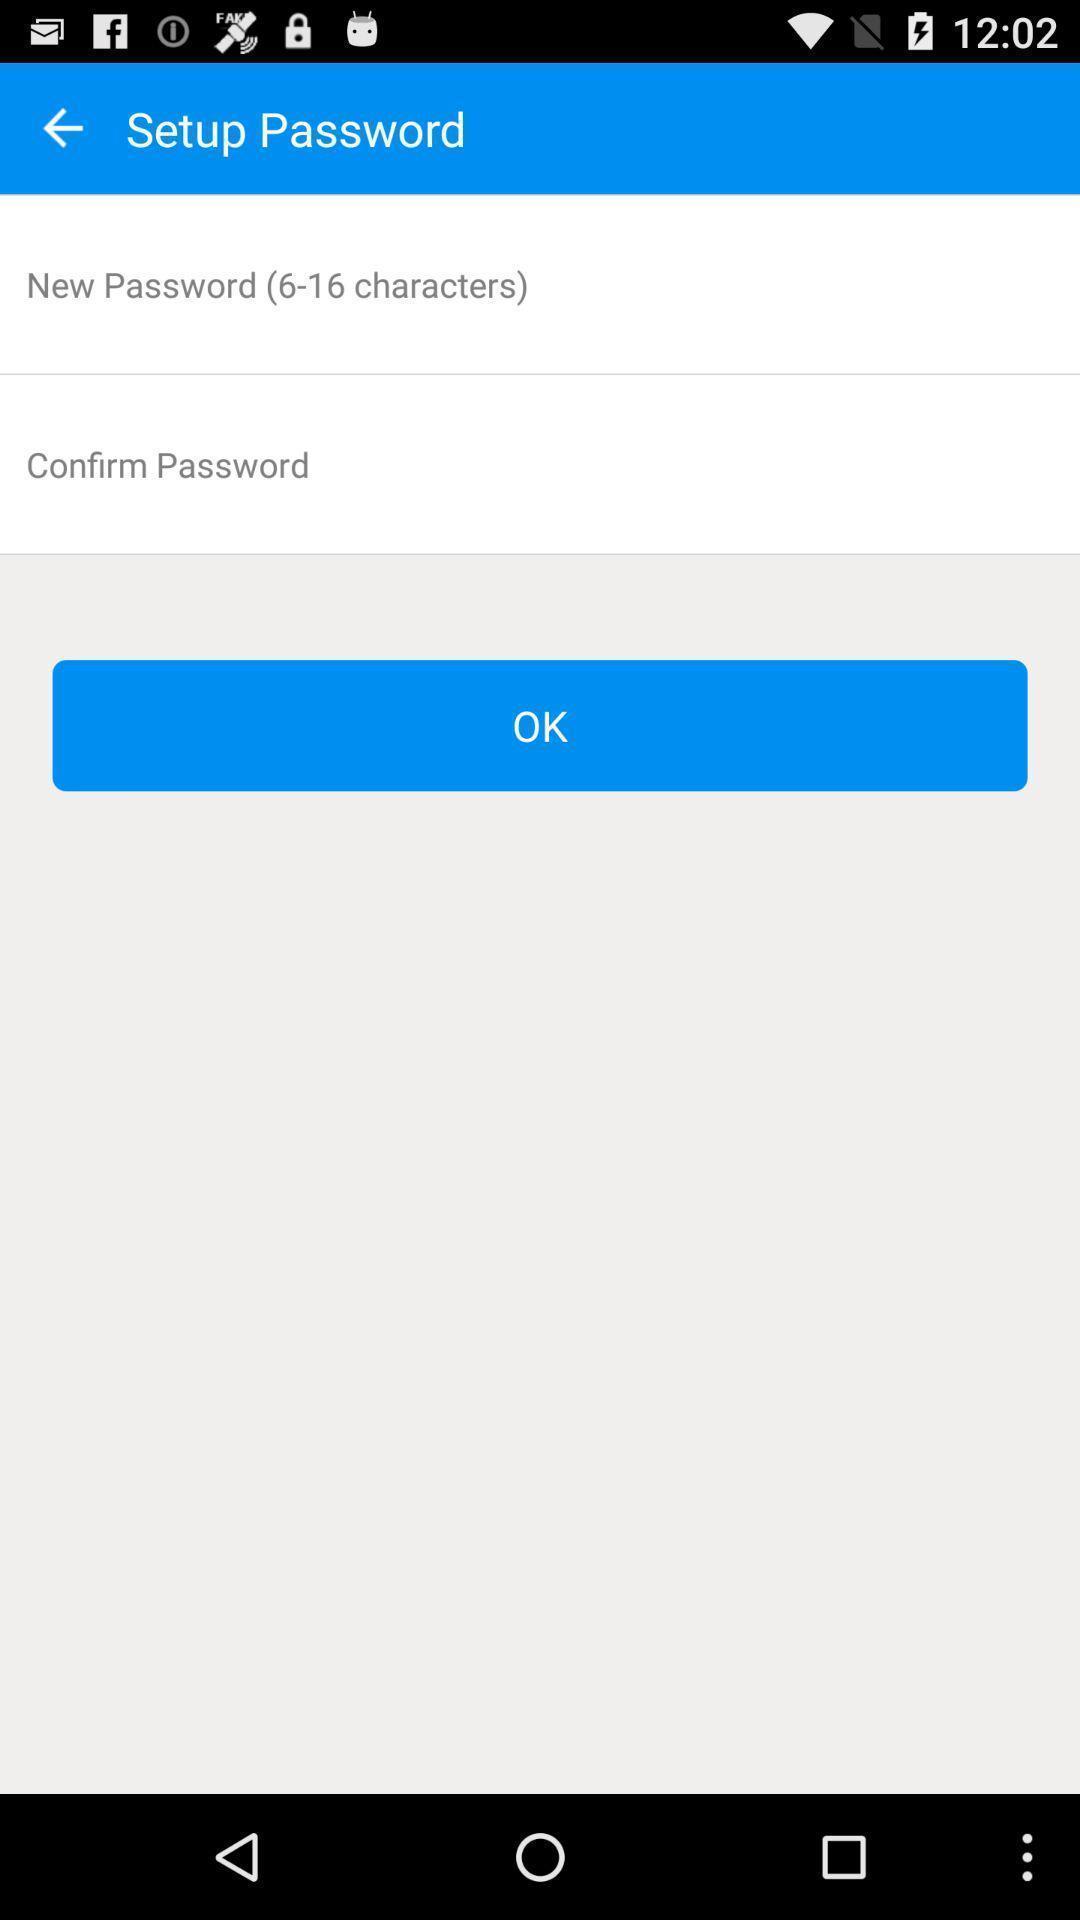Explain what's happening in this screen capture. Screen shows setup password options in a calling app. 